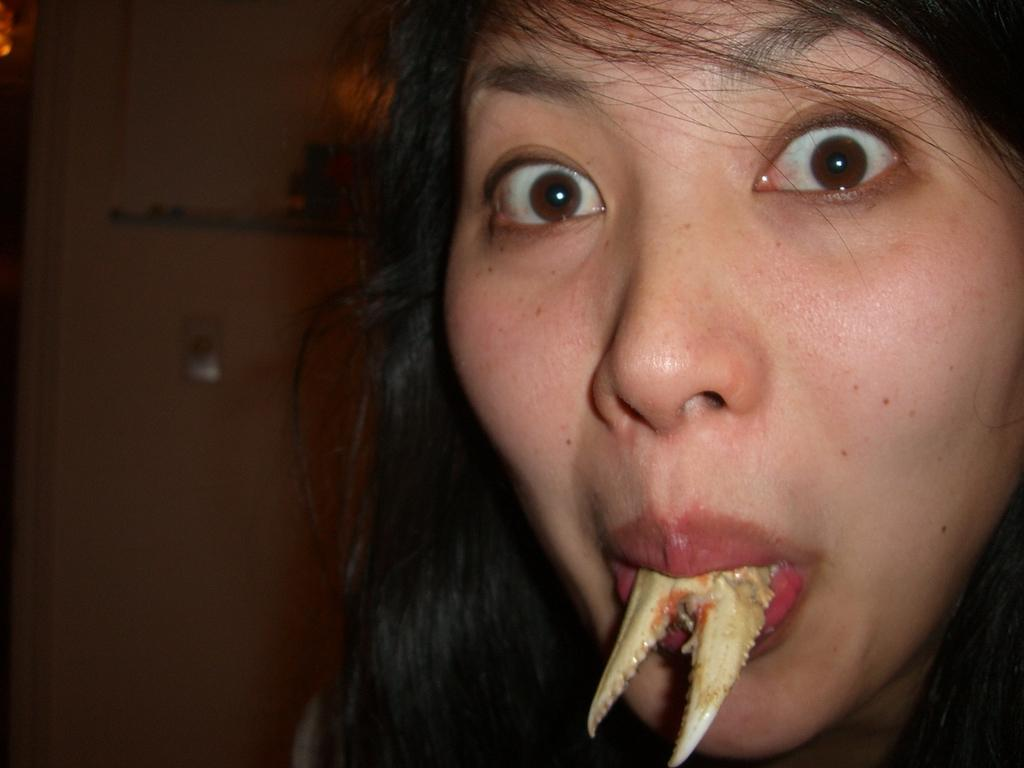What is the main subject of the image? There is a person in the image. What is the person doing in the image? There is an object inside the person's mouth. Can you describe the background of the image? The background of the image is dark. What type of wave can be seen crashing on the shore in the image? There is no wave or shore present in the image; it features a person with an object in their mouth against a dark background. 